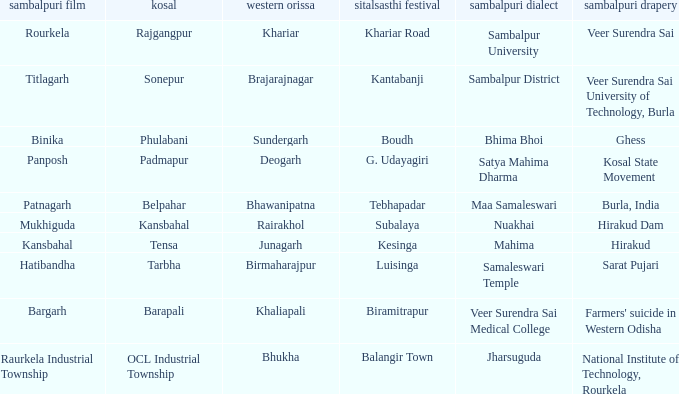What is the Kosal with a balangir town sitalsasthi carnival? OCL Industrial Township. 